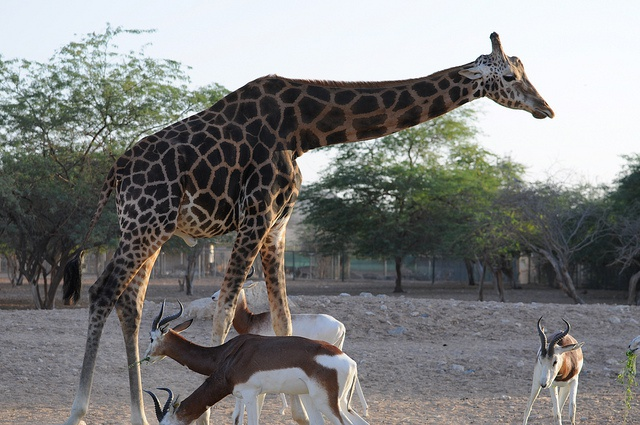Describe the objects in this image and their specific colors. I can see a giraffe in lavender, black, gray, and maroon tones in this image. 